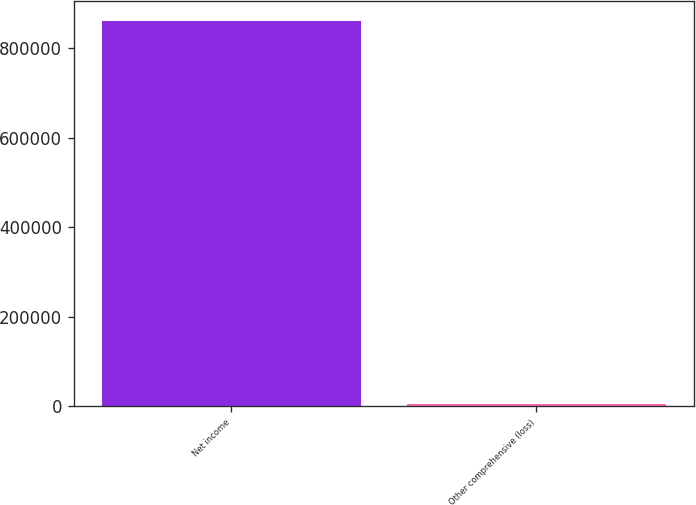<chart> <loc_0><loc_0><loc_500><loc_500><bar_chart><fcel>Net income<fcel>Other comprehensive (loss)<nl><fcel>861793<fcel>4357<nl></chart> 